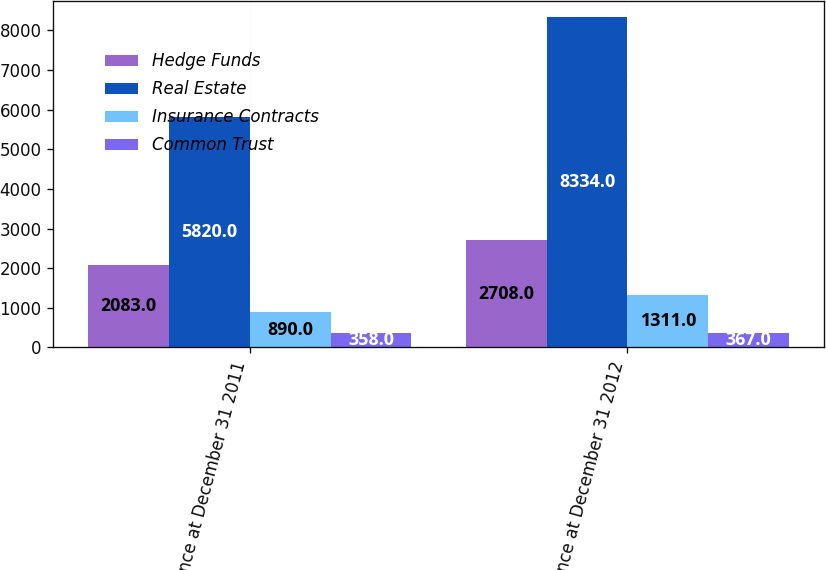<chart> <loc_0><loc_0><loc_500><loc_500><stacked_bar_chart><ecel><fcel>Balance at December 31 2011<fcel>Balance at December 31 2012<nl><fcel>Hedge Funds<fcel>2083<fcel>2708<nl><fcel>Real Estate<fcel>5820<fcel>8334<nl><fcel>Insurance Contracts<fcel>890<fcel>1311<nl><fcel>Common Trust<fcel>358<fcel>367<nl></chart> 